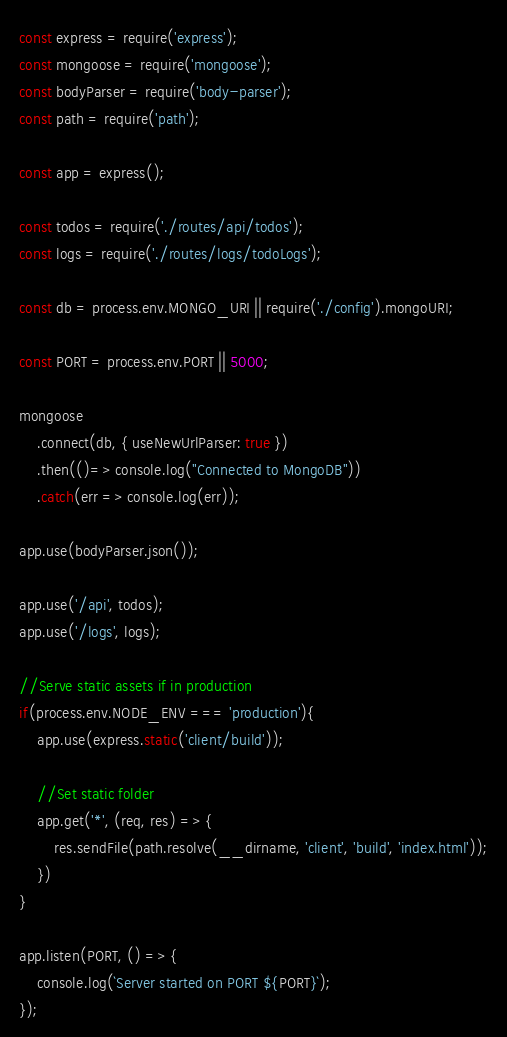Convert code to text. <code><loc_0><loc_0><loc_500><loc_500><_JavaScript_>const express = require('express');
const mongoose = require('mongoose');
const bodyParser = require('body-parser');
const path = require('path');

const app = express();

const todos = require('./routes/api/todos');
const logs = require('./routes/logs/todoLogs');

const db = process.env.MONGO_URI || require('./config').mongoURI;

const PORT = process.env.PORT || 5000;

mongoose
    .connect(db, { useNewUrlParser: true })
    .then(()=> console.log("Connected to MongoDB"))
    .catch(err => console.log(err));

app.use(bodyParser.json());

app.use('/api', todos);
app.use('/logs', logs);

//Serve static assets if in production
if(process.env.NODE_ENV === 'production'){
    app.use(express.static('client/build'));
    
    //Set static folder
    app.get('*', (req, res) => {
        res.sendFile(path.resolve(__dirname, 'client', 'build', 'index.html'));
    })
}

app.listen(PORT, () => {
    console.log(`Server started on PORT ${PORT}`);
});</code> 